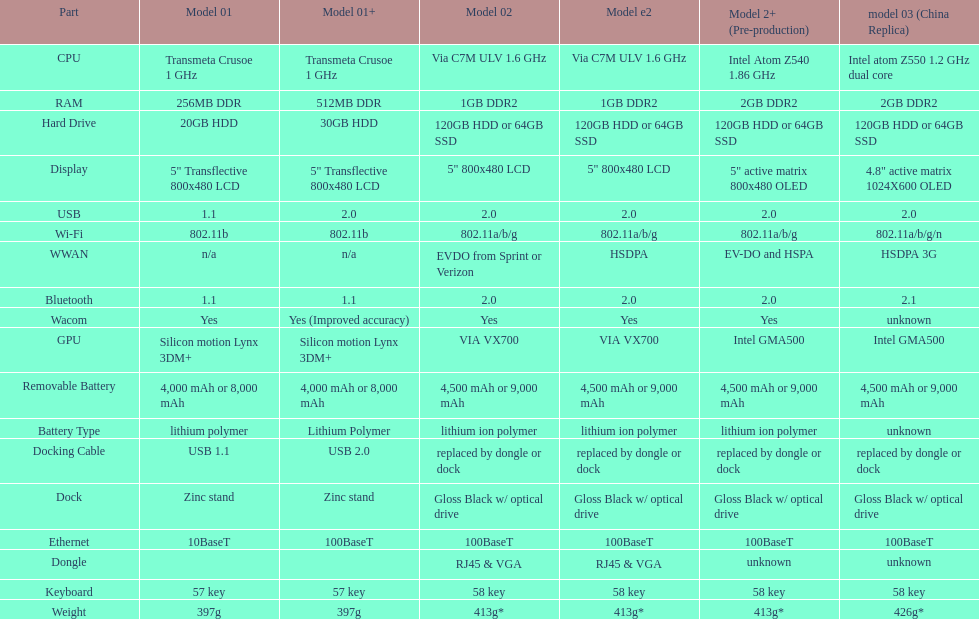How many models have 1.6ghz? 2. Could you parse the entire table? {'header': ['Part', 'Model 01', 'Model 01+', 'Model 02', 'Model e2', 'Model 2+ (Pre-production)', 'model 03 (China Replica)'], 'rows': [['CPU', 'Transmeta Crusoe 1\xa0GHz', 'Transmeta Crusoe 1\xa0GHz', 'Via C7M ULV 1.6\xa0GHz', 'Via C7M ULV 1.6\xa0GHz', 'Intel Atom Z540 1.86\xa0GHz', 'Intel atom Z550 1.2\xa0GHz dual core'], ['RAM', '256MB DDR', '512MB DDR', '1GB DDR2', '1GB DDR2', '2GB DDR2', '2GB DDR2'], ['Hard Drive', '20GB HDD', '30GB HDD', '120GB HDD or 64GB SSD', '120GB HDD or 64GB SSD', '120GB HDD or 64GB SSD', '120GB HDD or 64GB SSD'], ['Display', '5" Transflective 800x480 LCD', '5" Transflective 800x480 LCD', '5" 800x480 LCD', '5" 800x480 LCD', '5" active matrix 800x480 OLED', '4.8" active matrix 1024X600 OLED'], ['USB', '1.1', '2.0', '2.0', '2.0', '2.0', '2.0'], ['Wi-Fi', '802.11b', '802.11b', '802.11a/b/g', '802.11a/b/g', '802.11a/b/g', '802.11a/b/g/n'], ['WWAN', 'n/a', 'n/a', 'EVDO from Sprint or Verizon', 'HSDPA', 'EV-DO and HSPA', 'HSDPA 3G'], ['Bluetooth', '1.1', '1.1', '2.0', '2.0', '2.0', '2.1'], ['Wacom', 'Yes', 'Yes (Improved accuracy)', 'Yes', 'Yes', 'Yes', 'unknown'], ['GPU', 'Silicon motion Lynx 3DM+', 'Silicon motion Lynx 3DM+', 'VIA VX700', 'VIA VX700', 'Intel GMA500', 'Intel GMA500'], ['Removable Battery', '4,000 mAh or 8,000 mAh', '4,000 mAh or 8,000 mAh', '4,500 mAh or 9,000 mAh', '4,500 mAh or 9,000 mAh', '4,500 mAh or 9,000 mAh', '4,500 mAh or 9,000 mAh'], ['Battery Type', 'lithium polymer', 'Lithium Polymer', 'lithium ion polymer', 'lithium ion polymer', 'lithium ion polymer', 'unknown'], ['Docking Cable', 'USB 1.1', 'USB 2.0', 'replaced by dongle or dock', 'replaced by dongle or dock', 'replaced by dongle or dock', 'replaced by dongle or dock'], ['Dock', 'Zinc stand', 'Zinc stand', 'Gloss Black w/ optical drive', 'Gloss Black w/ optical drive', 'Gloss Black w/ optical drive', 'Gloss Black w/ optical drive'], ['Ethernet', '10BaseT', '100BaseT', '100BaseT', '100BaseT', '100BaseT', '100BaseT'], ['Dongle', '', '', 'RJ45 & VGA', 'RJ45 & VGA', 'unknown', 'unknown'], ['Keyboard', '57 key', '57 key', '58 key', '58 key', '58 key', '58 key'], ['Weight', '397g', '397g', '413g*', '413g*', '413g*', '426g*']]} 